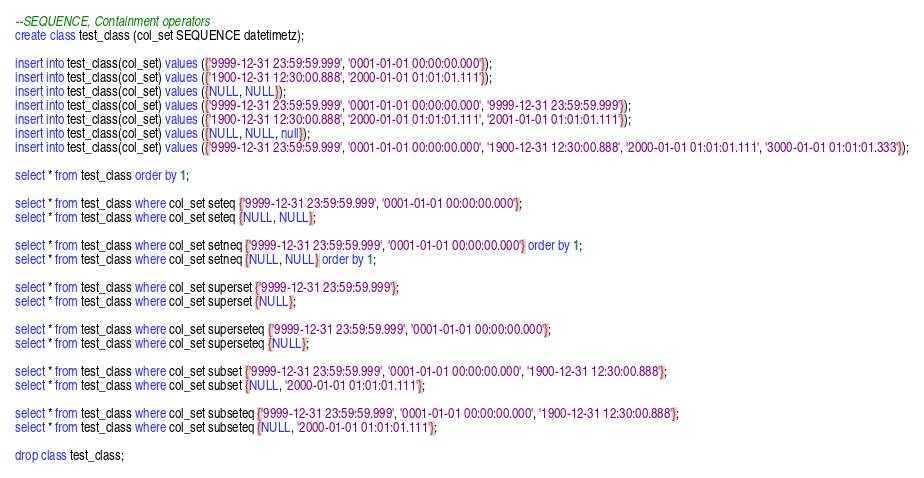<code> <loc_0><loc_0><loc_500><loc_500><_SQL_>--SEQUENCE, Containment operators
create class test_class (col_set SEQUENCE datetimetz);

insert into test_class(col_set) values ({'9999-12-31 23:59:59.999', '0001-01-01 00:00:00.000'});
insert into test_class(col_set) values ({'1900-12-31 12:30:00.888', '2000-01-01 01:01:01.111'});
insert into test_class(col_set) values ({NULL, NULL});
insert into test_class(col_set) values ({'9999-12-31 23:59:59.999', '0001-01-01 00:00:00.000', '9999-12-31 23:59:59.999'});
insert into test_class(col_set) values ({'1900-12-31 12:30:00.888', '2000-01-01 01:01:01.111', '2001-01-01 01:01:01.111'});
insert into test_class(col_set) values ({NULL, NULL, null});
insert into test_class(col_set) values ({'9999-12-31 23:59:59.999', '0001-01-01 00:00:00.000', '1900-12-31 12:30:00.888', '2000-01-01 01:01:01.111', '3000-01-01 01:01:01.333'});

select * from test_class order by 1;

select * from test_class where col_set seteq {'9999-12-31 23:59:59.999', '0001-01-01 00:00:00.000'};
select * from test_class where col_set seteq {NULL, NULL};

select * from test_class where col_set setneq {'9999-12-31 23:59:59.999', '0001-01-01 00:00:00.000'} order by 1;
select * from test_class where col_set setneq {NULL, NULL} order by 1;

select * from test_class where col_set superset {'9999-12-31 23:59:59.999'};
select * from test_class where col_set superset {NULL};

select * from test_class where col_set superseteq {'9999-12-31 23:59:59.999', '0001-01-01 00:00:00.000'};
select * from test_class where col_set superseteq {NULL};

select * from test_class where col_set subset {'9999-12-31 23:59:59.999', '0001-01-01 00:00:00.000', '1900-12-31 12:30:00.888'};
select * from test_class where col_set subset {NULL, '2000-01-01 01:01:01.111'};

select * from test_class where col_set subseteq {'9999-12-31 23:59:59.999', '0001-01-01 00:00:00.000', '1900-12-31 12:30:00.888'};
select * from test_class where col_set subseteq {NULL, '2000-01-01 01:01:01.111'};

drop class test_class;</code> 